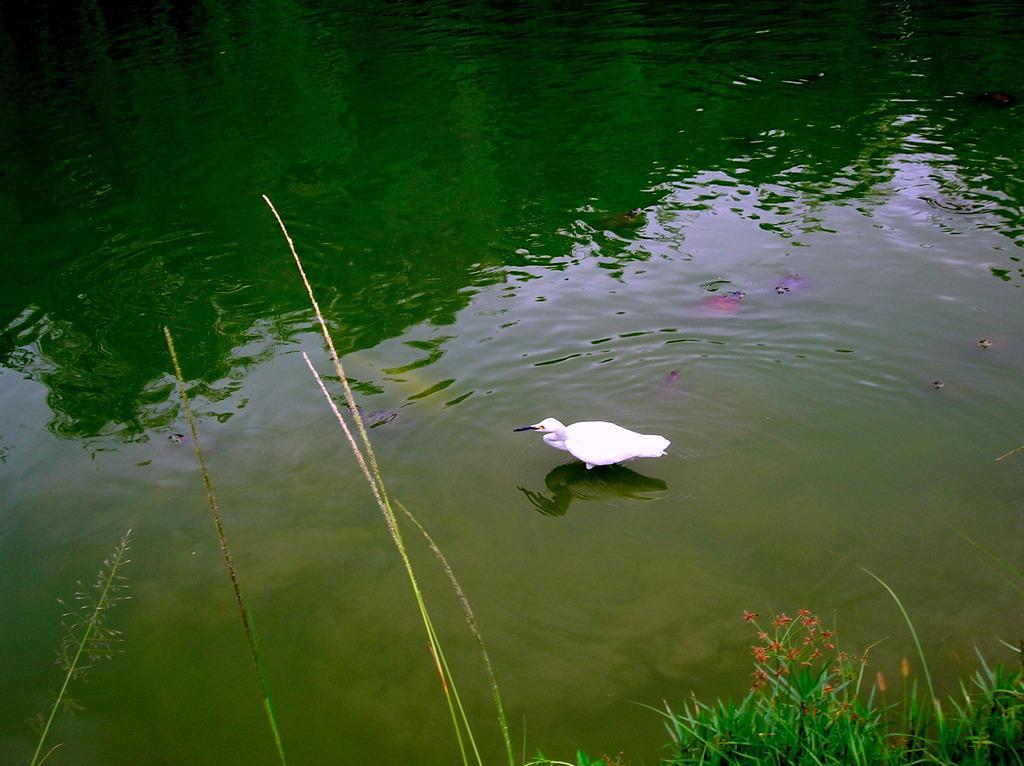How would you summarize this image in a sentence or two? In this picture we can see fishes in the water, in the middle of the image we can see a bird, at the bottom of the image we can see plants. 